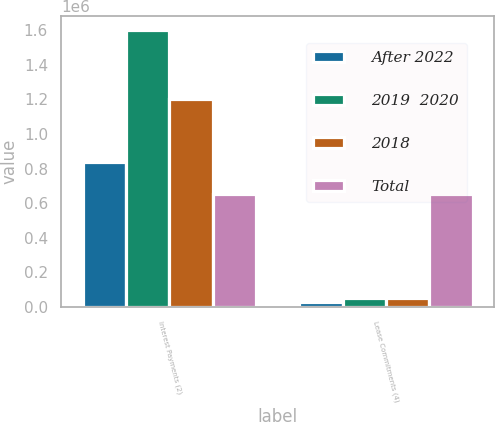<chart> <loc_0><loc_0><loc_500><loc_500><stacked_bar_chart><ecel><fcel>Interest Payments (2)<fcel>Lease Commitments (4)<nl><fcel>After 2022<fcel>837976<fcel>26401<nl><fcel>2019  2020<fcel>1.603e+06<fcel>50765<nl><fcel>2018<fcel>1.2e+06<fcel>47947<nl><fcel>Total<fcel>655309<fcel>655309<nl></chart> 